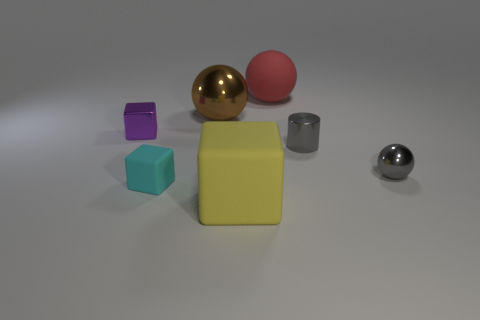Can you describe the materials of the objects in the image? In the image, we have objects that exhibit different material properties. The golden sphere and the smaller silver sphere present a shiny, reflective surface suggesting that they are metallic. The large yellow block and the purple cube, as mentioned earlier, might be made of rubber due to their matte finish. The red sphere could be either plastic or rubber, depending on its actual tactile quality which cannot be determined from the image alone.  Are there any objects that stand out to you in terms of shape or color? Certainly! The golden sphere stands out with its shiny surface and distinct color, setting it apart from the more muted colors of the other objects. In terms of shape, while most objects are regular geometric shapes, the large yellow block is notably larger than the others, making it quite prominent. 